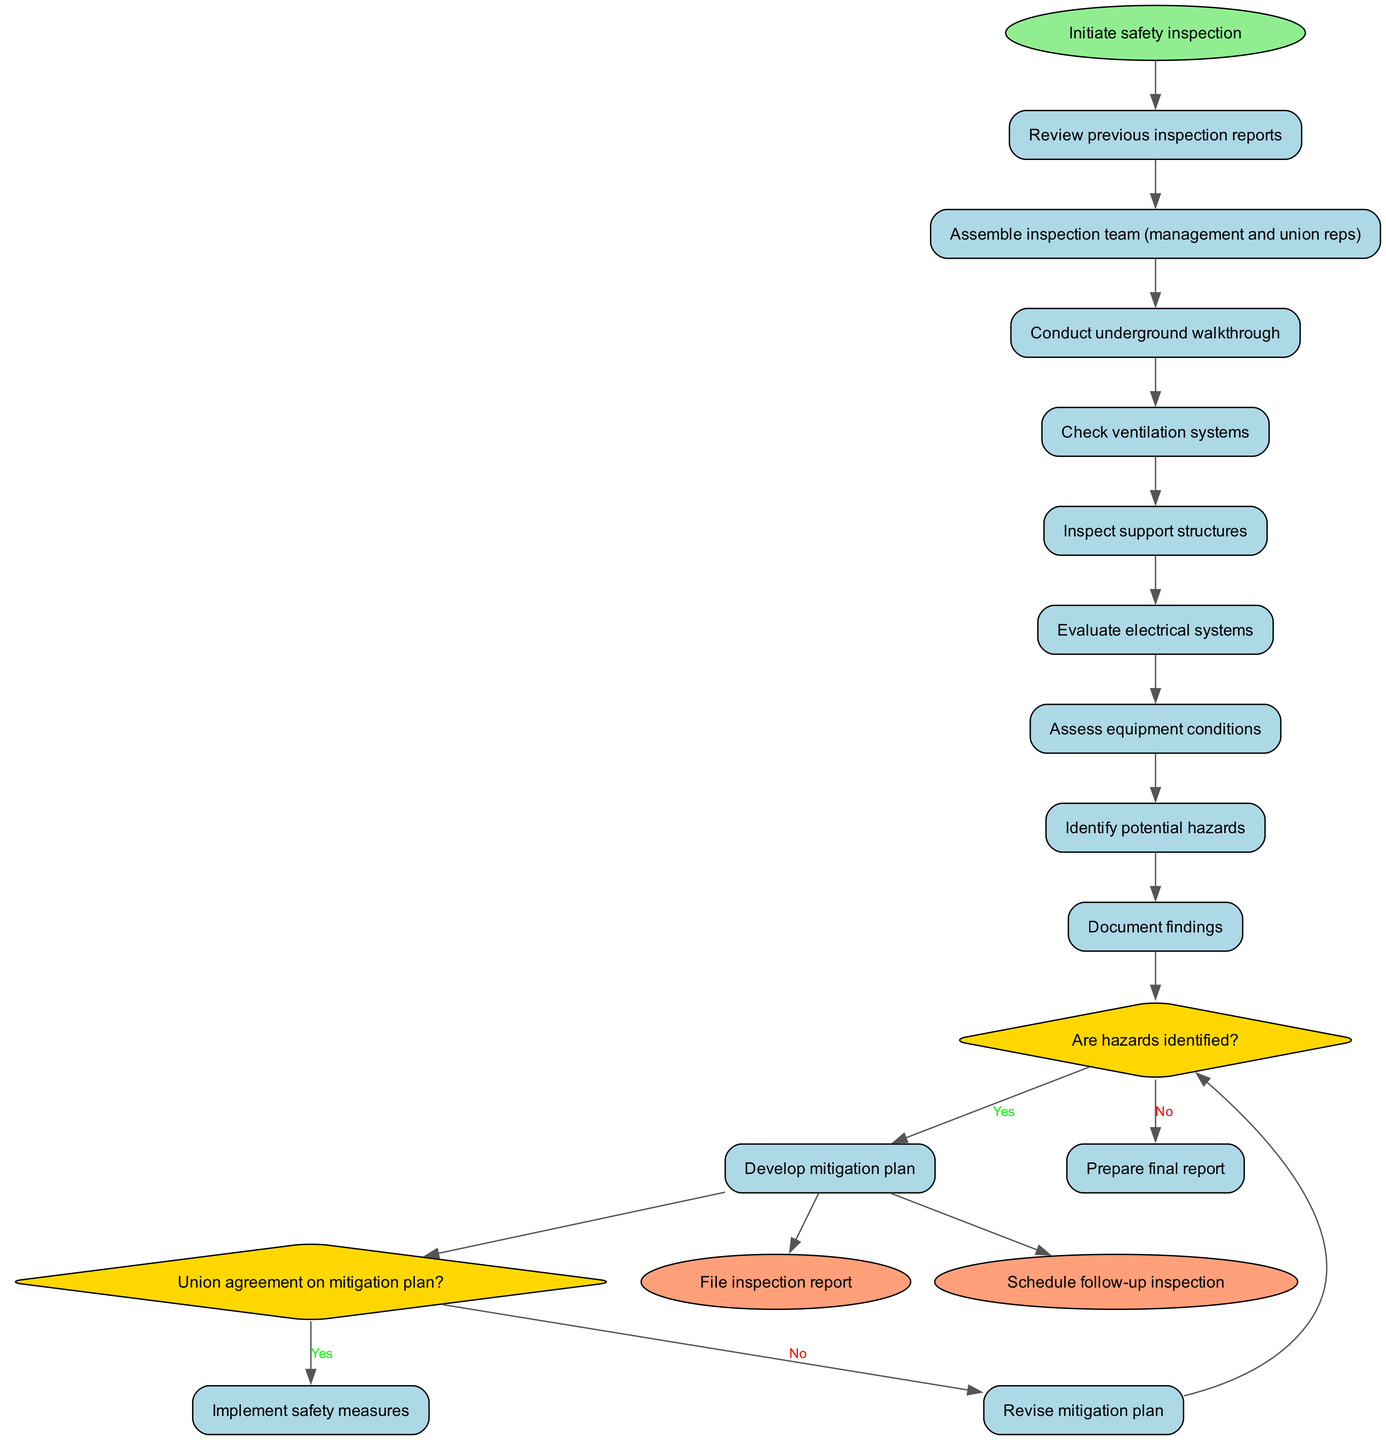What is the starting point of the procedure? The starting point of the procedure is specified as "Initiate safety inspection" in the diagram.
Answer: Initiate safety inspection How many activities are listed in the inspection? By counting the activities provided in the diagram, there are eight activities listed in total.
Answer: 8 What happens if hazards are identified? According to the diagram, if hazards are identified, the next step is to "Develop mitigation plan".
Answer: Develop mitigation plan Is there a decision point after assessing equipment conditions? Yes, there is a decision point after assessing equipment conditions that asks whether hazards are identified.
Answer: Yes If the union does not agree on the mitigation plan, what is the next action? The diagram indicates that if the union does not agree on the mitigation plan, the next action is to "Revise mitigation plan".
Answer: Revise mitigation plan What role does the inspection team have in the process? The inspection team's role is to conduct the safety inspection through the various activities outlined in the diagram, which includes assessing conditions and documenting findings.
Answer: Conduct safety inspection After filing the inspection report, what is the final step in the procedure? According to the diagram, after filing the inspection report, the final step is to "Schedule follow-up inspection."
Answer: Schedule follow-up inspection What is the nature of the decision nodes in the diagram? The decision nodes in the diagram are questions that determine the flow of the process based on the answers given, directing the next action accordingly.
Answer: Questions directing flow How is the relationship between the mitigation plan and the union's agreement represented? The relationship is represented through a decision node that questions whether the union agrees on the mitigation plan, influencing the next steps in the process.
Answer: Decision node influences next steps 